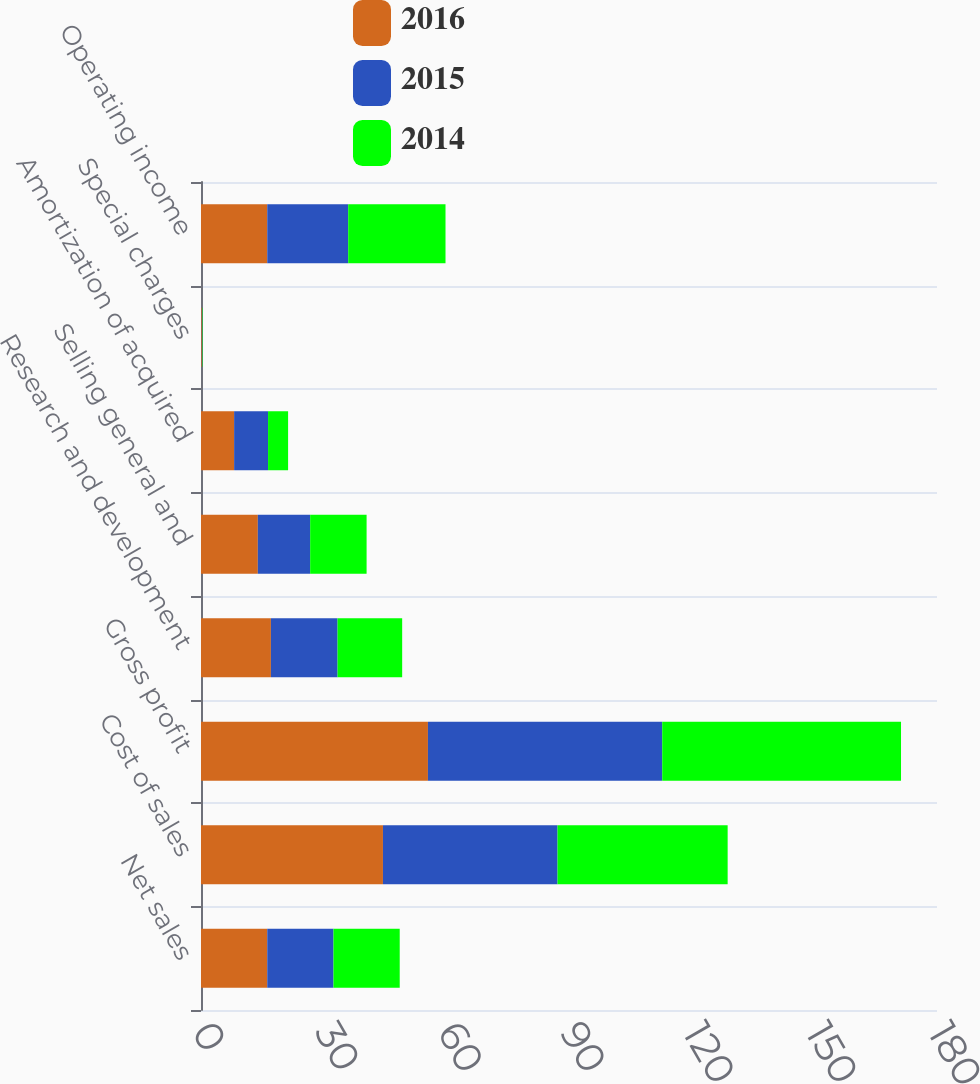Convert chart to OTSL. <chart><loc_0><loc_0><loc_500><loc_500><stacked_bar_chart><ecel><fcel>Net sales<fcel>Cost of sales<fcel>Gross profit<fcel>Research and development<fcel>Selling general and<fcel>Amortization of acquired<fcel>Special charges<fcel>Operating income<nl><fcel>2016<fcel>16.2<fcel>44.5<fcel>55.5<fcel>17.1<fcel>13.9<fcel>8.1<fcel>0.2<fcel>16.2<nl><fcel>2015<fcel>16.2<fcel>42.7<fcel>57.3<fcel>16.3<fcel>12.8<fcel>8.3<fcel>0.1<fcel>19.8<nl><fcel>2014<fcel>16.2<fcel>41.6<fcel>58.4<fcel>15.8<fcel>13.8<fcel>4.9<fcel>0.1<fcel>23.8<nl></chart> 